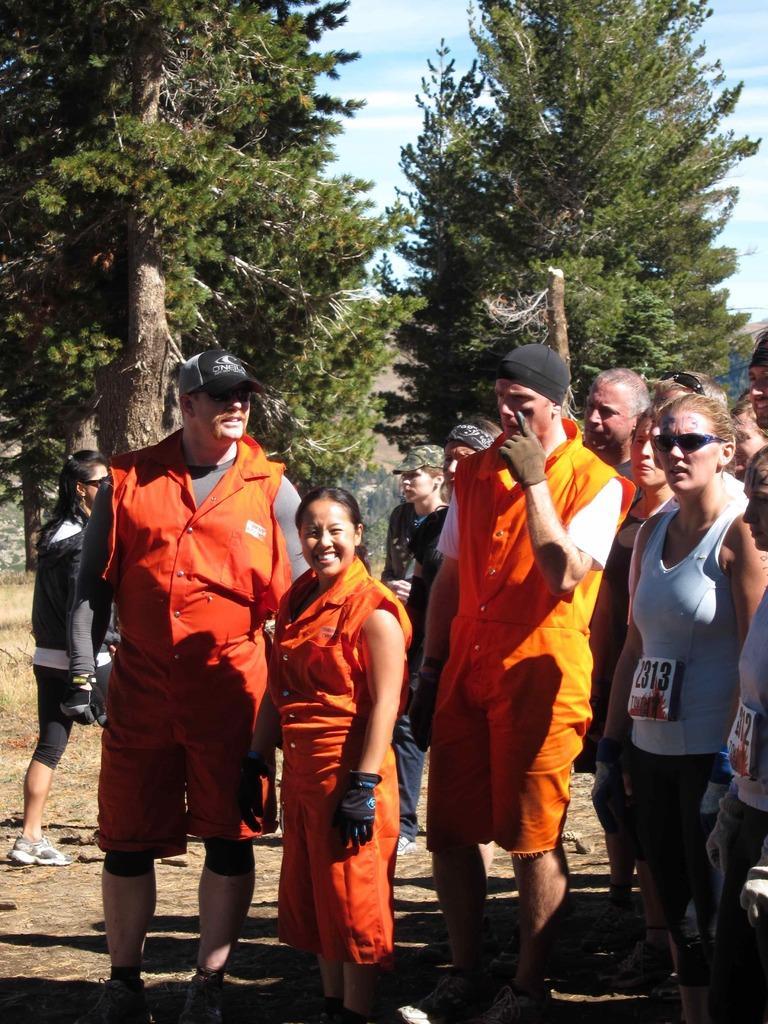Describe this image in one or two sentences. In this image, we can see a group of people standing and wearing clothes. There are trees in the middle of the image. There is a sky at the top of the image. 